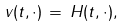<formula> <loc_0><loc_0><loc_500><loc_500>v ( t , \cdot ) \, = \, H ( t , \cdot ) ,</formula> 